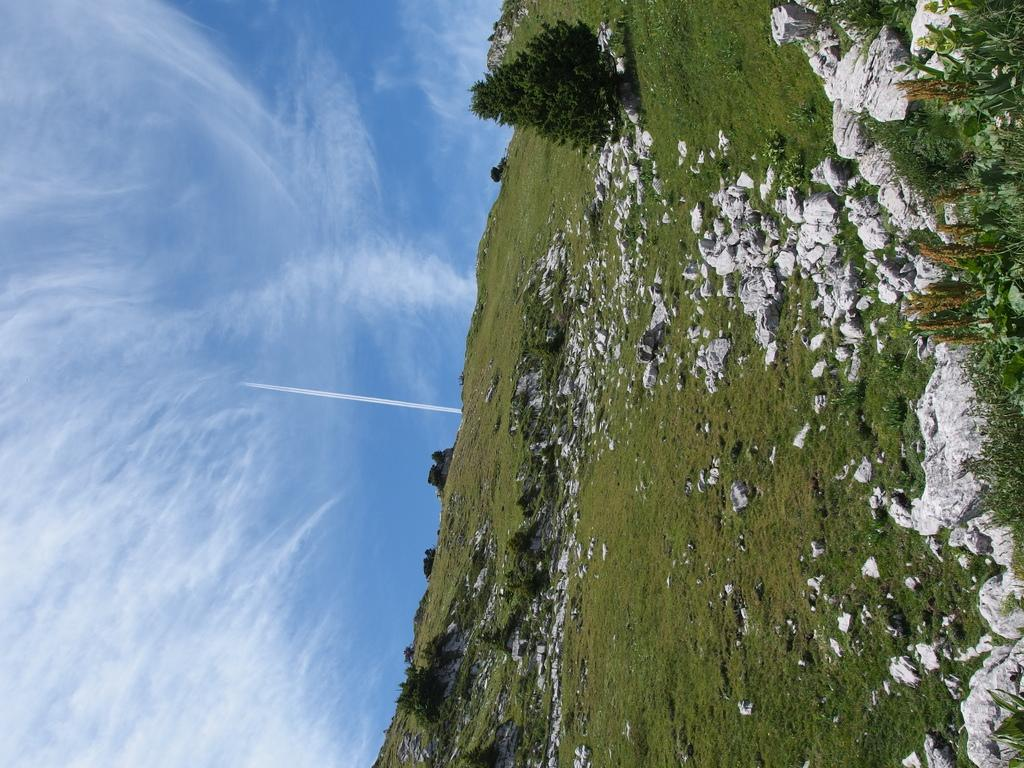What type of natural formation can be seen in the image? There are mountains in the image. What type of rocks are present in the image? There are white rocks in the image. What type of vegetation can be seen in the image? There are trees, bushes, and plants in the image. What is the color of the grass in the image? The grass in the image is green. What is visible at the top of the image? The sky is visible at the top of the image. Where is the downtown area in the image? There is no downtown area present in the image; it features natural landscapes. What type of brush is used to paint the letter on the rocks in the image? There is no letter or brush present in the image; it features natural landscapes with rocks and vegetation. 